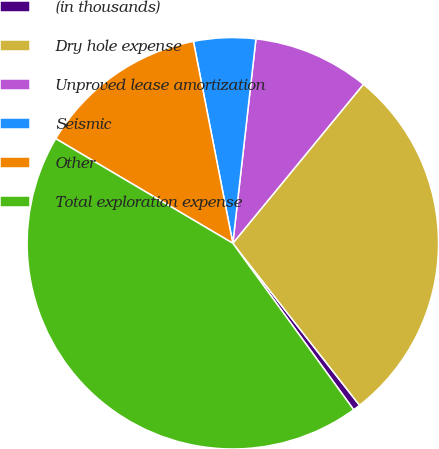Convert chart to OTSL. <chart><loc_0><loc_0><loc_500><loc_500><pie_chart><fcel>(in thousands)<fcel>Dry hole expense<fcel>Unproved lease amortization<fcel>Seismic<fcel>Other<fcel>Total exploration expense<nl><fcel>0.57%<fcel>28.49%<fcel>9.15%<fcel>4.86%<fcel>13.44%<fcel>43.48%<nl></chart> 